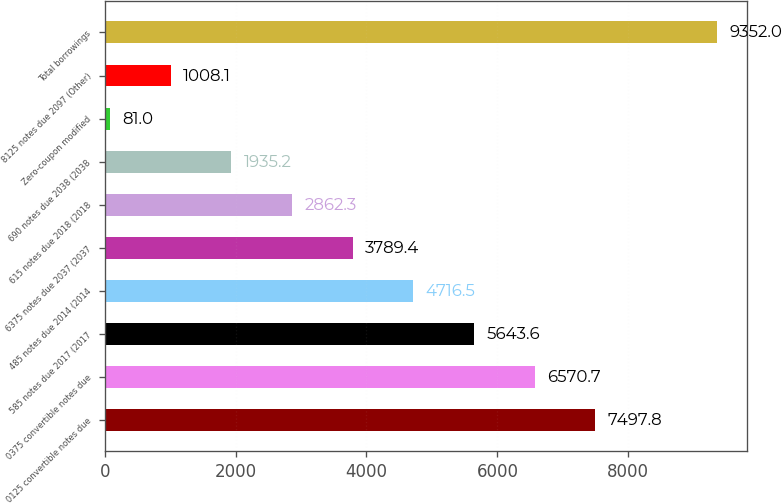<chart> <loc_0><loc_0><loc_500><loc_500><bar_chart><fcel>0125 convertible notes due<fcel>0375 convertible notes due<fcel>585 notes due 2017 (2017<fcel>485 notes due 2014 (2014<fcel>6375 notes due 2037 (2037<fcel>615 notes due 2018 (2018<fcel>690 notes due 2038 (2038<fcel>Zero-coupon modified<fcel>8125 notes due 2097 (Other)<fcel>Total borrowings<nl><fcel>7497.8<fcel>6570.7<fcel>5643.6<fcel>4716.5<fcel>3789.4<fcel>2862.3<fcel>1935.2<fcel>81<fcel>1008.1<fcel>9352<nl></chart> 